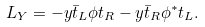<formula> <loc_0><loc_0><loc_500><loc_500>L _ { Y } = - y \bar { t } _ { L } \phi t _ { R } - y \bar { t } _ { R } \phi ^ { * } t _ { L } .</formula> 